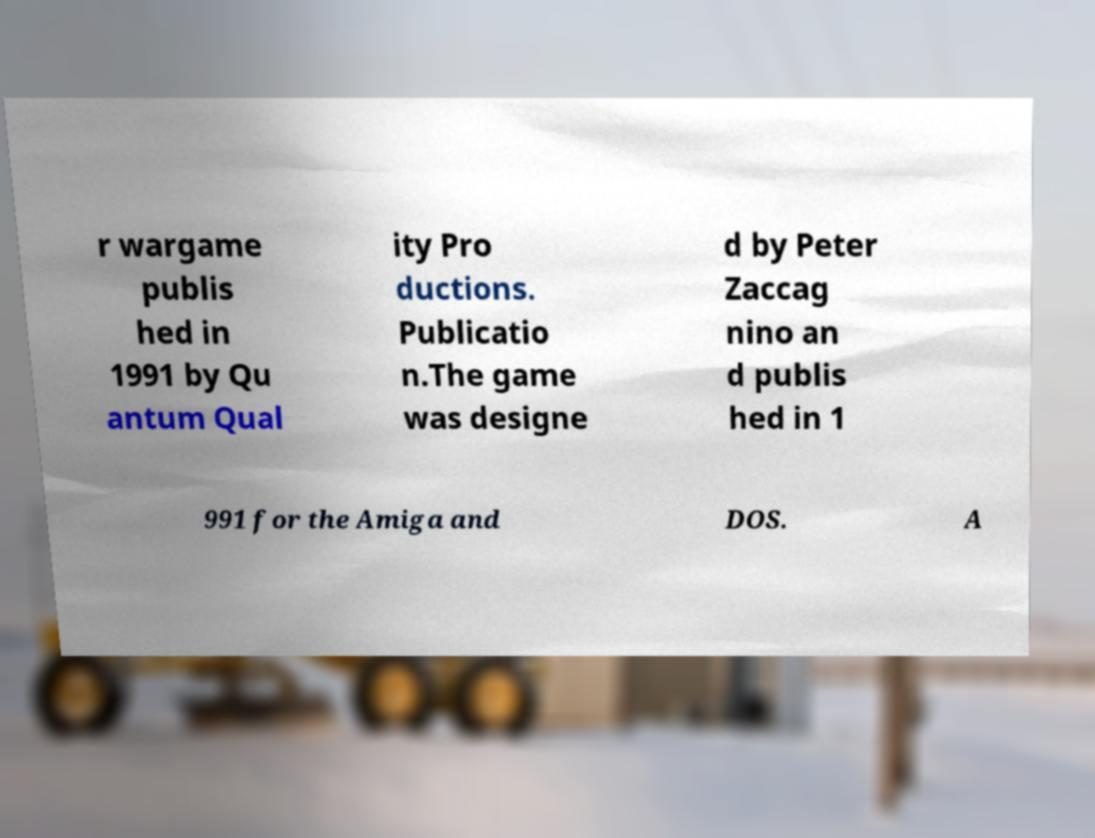Can you accurately transcribe the text from the provided image for me? r wargame publis hed in 1991 by Qu antum Qual ity Pro ductions. Publicatio n.The game was designe d by Peter Zaccag nino an d publis hed in 1 991 for the Amiga and DOS. A 